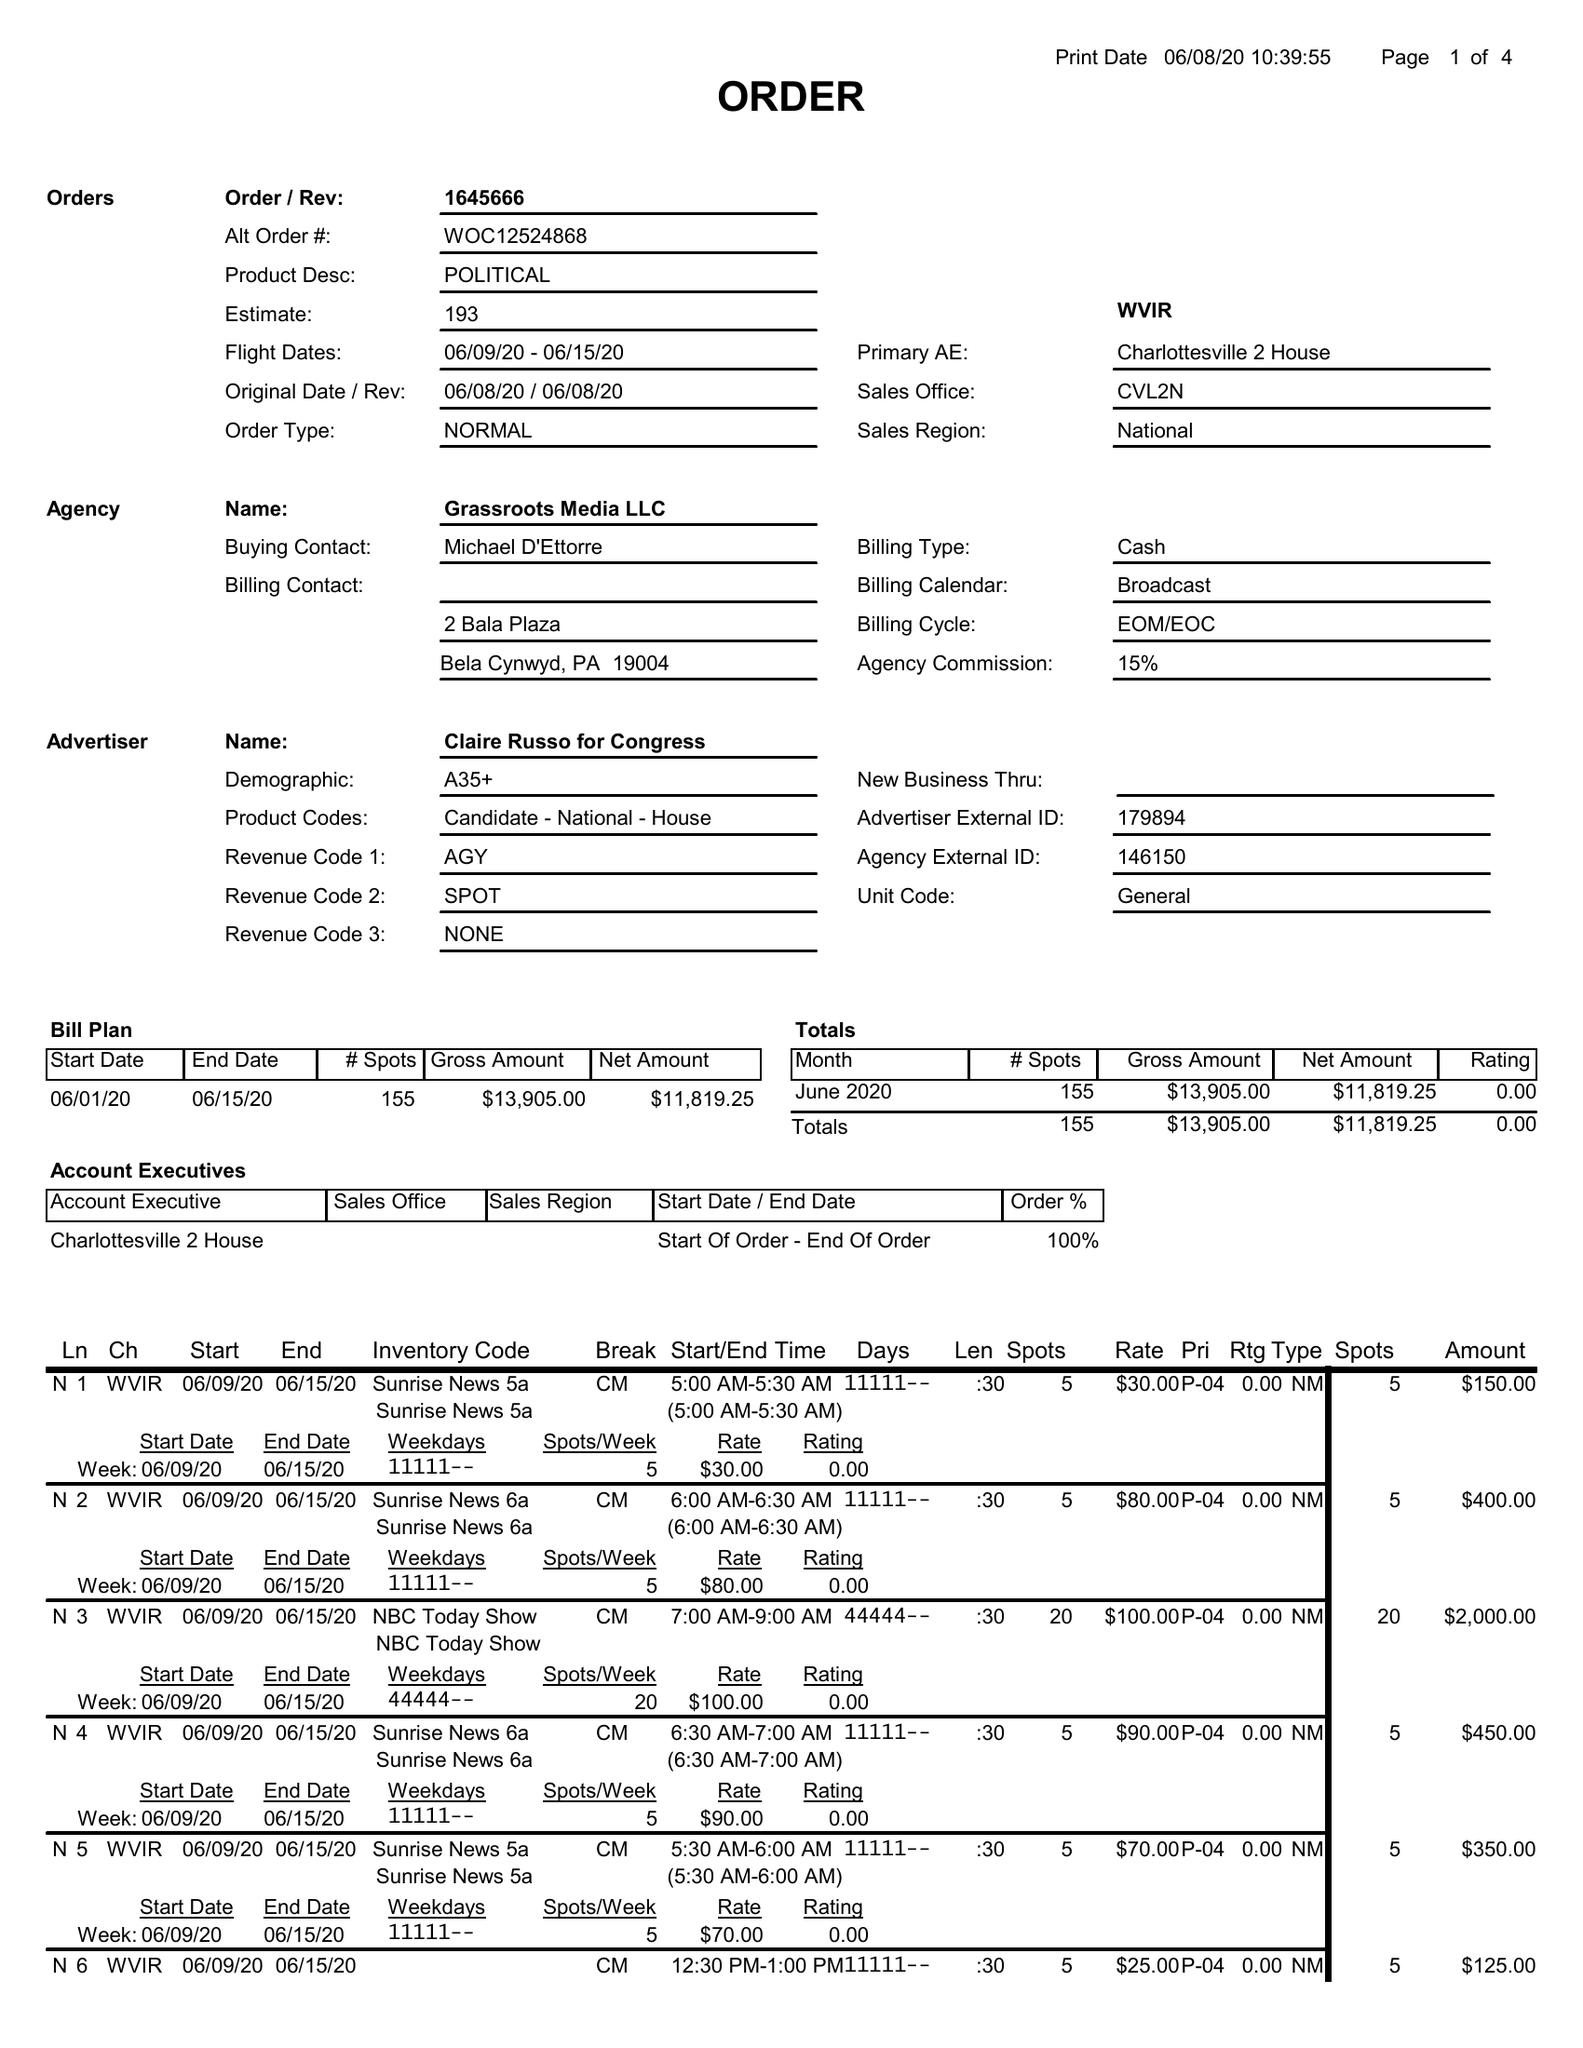What is the value for the contract_num?
Answer the question using a single word or phrase. 1645666 